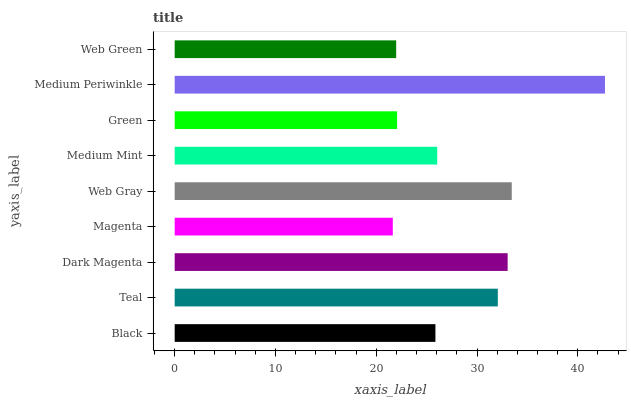Is Magenta the minimum?
Answer yes or no. Yes. Is Medium Periwinkle the maximum?
Answer yes or no. Yes. Is Teal the minimum?
Answer yes or no. No. Is Teal the maximum?
Answer yes or no. No. Is Teal greater than Black?
Answer yes or no. Yes. Is Black less than Teal?
Answer yes or no. Yes. Is Black greater than Teal?
Answer yes or no. No. Is Teal less than Black?
Answer yes or no. No. Is Medium Mint the high median?
Answer yes or no. Yes. Is Medium Mint the low median?
Answer yes or no. Yes. Is Web Green the high median?
Answer yes or no. No. Is Teal the low median?
Answer yes or no. No. 